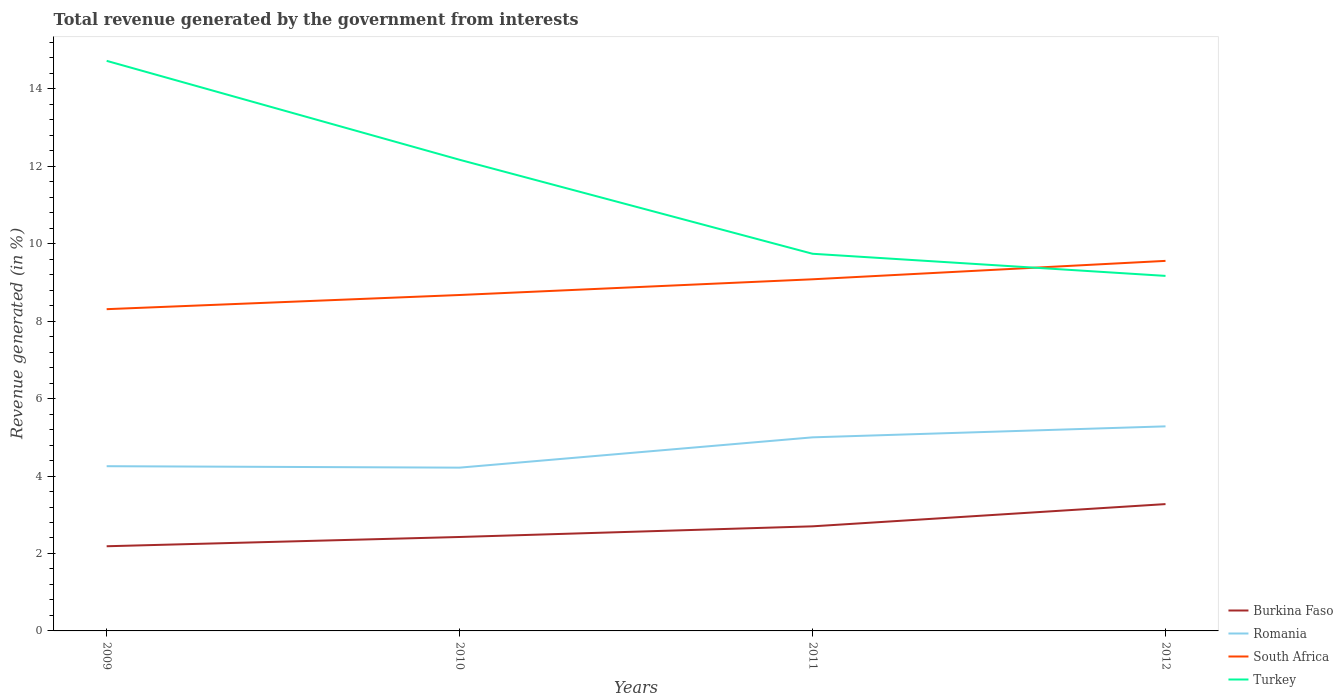Across all years, what is the maximum total revenue generated in Burkina Faso?
Offer a terse response. 2.19. What is the total total revenue generated in Romania in the graph?
Provide a succinct answer. -0.75. What is the difference between the highest and the second highest total revenue generated in South Africa?
Provide a short and direct response. 1.25. How many lines are there?
Make the answer very short. 4. What is the difference between two consecutive major ticks on the Y-axis?
Provide a short and direct response. 2. Does the graph contain grids?
Your answer should be very brief. No. How many legend labels are there?
Your response must be concise. 4. How are the legend labels stacked?
Provide a succinct answer. Vertical. What is the title of the graph?
Provide a short and direct response. Total revenue generated by the government from interests. What is the label or title of the X-axis?
Provide a succinct answer. Years. What is the label or title of the Y-axis?
Keep it short and to the point. Revenue generated (in %). What is the Revenue generated (in %) in Burkina Faso in 2009?
Ensure brevity in your answer.  2.19. What is the Revenue generated (in %) of Romania in 2009?
Your answer should be compact. 4.25. What is the Revenue generated (in %) of South Africa in 2009?
Give a very brief answer. 8.31. What is the Revenue generated (in %) of Turkey in 2009?
Offer a very short reply. 14.72. What is the Revenue generated (in %) in Burkina Faso in 2010?
Your answer should be compact. 2.43. What is the Revenue generated (in %) of Romania in 2010?
Provide a succinct answer. 4.22. What is the Revenue generated (in %) of South Africa in 2010?
Your answer should be very brief. 8.68. What is the Revenue generated (in %) in Turkey in 2010?
Your answer should be very brief. 12.17. What is the Revenue generated (in %) in Burkina Faso in 2011?
Offer a very short reply. 2.7. What is the Revenue generated (in %) of Romania in 2011?
Ensure brevity in your answer.  5. What is the Revenue generated (in %) in South Africa in 2011?
Offer a terse response. 9.08. What is the Revenue generated (in %) of Turkey in 2011?
Provide a short and direct response. 9.74. What is the Revenue generated (in %) of Burkina Faso in 2012?
Provide a succinct answer. 3.28. What is the Revenue generated (in %) of Romania in 2012?
Provide a short and direct response. 5.28. What is the Revenue generated (in %) in South Africa in 2012?
Ensure brevity in your answer.  9.56. What is the Revenue generated (in %) in Turkey in 2012?
Offer a very short reply. 9.17. Across all years, what is the maximum Revenue generated (in %) in Burkina Faso?
Offer a terse response. 3.28. Across all years, what is the maximum Revenue generated (in %) in Romania?
Give a very brief answer. 5.28. Across all years, what is the maximum Revenue generated (in %) in South Africa?
Your response must be concise. 9.56. Across all years, what is the maximum Revenue generated (in %) in Turkey?
Provide a short and direct response. 14.72. Across all years, what is the minimum Revenue generated (in %) in Burkina Faso?
Give a very brief answer. 2.19. Across all years, what is the minimum Revenue generated (in %) in Romania?
Ensure brevity in your answer.  4.22. Across all years, what is the minimum Revenue generated (in %) in South Africa?
Make the answer very short. 8.31. Across all years, what is the minimum Revenue generated (in %) in Turkey?
Give a very brief answer. 9.17. What is the total Revenue generated (in %) of Burkina Faso in the graph?
Your response must be concise. 10.59. What is the total Revenue generated (in %) of Romania in the graph?
Your answer should be compact. 18.75. What is the total Revenue generated (in %) of South Africa in the graph?
Keep it short and to the point. 35.62. What is the total Revenue generated (in %) in Turkey in the graph?
Provide a succinct answer. 45.8. What is the difference between the Revenue generated (in %) in Burkina Faso in 2009 and that in 2010?
Your response must be concise. -0.24. What is the difference between the Revenue generated (in %) in Romania in 2009 and that in 2010?
Provide a succinct answer. 0.04. What is the difference between the Revenue generated (in %) in South Africa in 2009 and that in 2010?
Offer a terse response. -0.37. What is the difference between the Revenue generated (in %) in Turkey in 2009 and that in 2010?
Keep it short and to the point. 2.56. What is the difference between the Revenue generated (in %) of Burkina Faso in 2009 and that in 2011?
Offer a terse response. -0.51. What is the difference between the Revenue generated (in %) of Romania in 2009 and that in 2011?
Keep it short and to the point. -0.75. What is the difference between the Revenue generated (in %) in South Africa in 2009 and that in 2011?
Offer a terse response. -0.77. What is the difference between the Revenue generated (in %) of Turkey in 2009 and that in 2011?
Give a very brief answer. 4.98. What is the difference between the Revenue generated (in %) of Burkina Faso in 2009 and that in 2012?
Provide a succinct answer. -1.09. What is the difference between the Revenue generated (in %) in Romania in 2009 and that in 2012?
Offer a terse response. -1.03. What is the difference between the Revenue generated (in %) in South Africa in 2009 and that in 2012?
Your answer should be compact. -1.25. What is the difference between the Revenue generated (in %) of Turkey in 2009 and that in 2012?
Offer a terse response. 5.55. What is the difference between the Revenue generated (in %) of Burkina Faso in 2010 and that in 2011?
Provide a short and direct response. -0.28. What is the difference between the Revenue generated (in %) of Romania in 2010 and that in 2011?
Provide a short and direct response. -0.78. What is the difference between the Revenue generated (in %) of South Africa in 2010 and that in 2011?
Ensure brevity in your answer.  -0.41. What is the difference between the Revenue generated (in %) in Turkey in 2010 and that in 2011?
Offer a terse response. 2.43. What is the difference between the Revenue generated (in %) of Burkina Faso in 2010 and that in 2012?
Your response must be concise. -0.85. What is the difference between the Revenue generated (in %) of Romania in 2010 and that in 2012?
Your response must be concise. -1.07. What is the difference between the Revenue generated (in %) of South Africa in 2010 and that in 2012?
Ensure brevity in your answer.  -0.88. What is the difference between the Revenue generated (in %) of Turkey in 2010 and that in 2012?
Offer a terse response. 3. What is the difference between the Revenue generated (in %) in Burkina Faso in 2011 and that in 2012?
Your response must be concise. -0.57. What is the difference between the Revenue generated (in %) in Romania in 2011 and that in 2012?
Provide a succinct answer. -0.28. What is the difference between the Revenue generated (in %) of South Africa in 2011 and that in 2012?
Offer a terse response. -0.48. What is the difference between the Revenue generated (in %) of Turkey in 2011 and that in 2012?
Keep it short and to the point. 0.57. What is the difference between the Revenue generated (in %) in Burkina Faso in 2009 and the Revenue generated (in %) in Romania in 2010?
Your answer should be very brief. -2.03. What is the difference between the Revenue generated (in %) in Burkina Faso in 2009 and the Revenue generated (in %) in South Africa in 2010?
Offer a very short reply. -6.49. What is the difference between the Revenue generated (in %) in Burkina Faso in 2009 and the Revenue generated (in %) in Turkey in 2010?
Your answer should be compact. -9.98. What is the difference between the Revenue generated (in %) in Romania in 2009 and the Revenue generated (in %) in South Africa in 2010?
Make the answer very short. -4.42. What is the difference between the Revenue generated (in %) in Romania in 2009 and the Revenue generated (in %) in Turkey in 2010?
Keep it short and to the point. -7.91. What is the difference between the Revenue generated (in %) in South Africa in 2009 and the Revenue generated (in %) in Turkey in 2010?
Keep it short and to the point. -3.86. What is the difference between the Revenue generated (in %) in Burkina Faso in 2009 and the Revenue generated (in %) in Romania in 2011?
Offer a very short reply. -2.81. What is the difference between the Revenue generated (in %) of Burkina Faso in 2009 and the Revenue generated (in %) of South Africa in 2011?
Offer a terse response. -6.89. What is the difference between the Revenue generated (in %) in Burkina Faso in 2009 and the Revenue generated (in %) in Turkey in 2011?
Make the answer very short. -7.55. What is the difference between the Revenue generated (in %) in Romania in 2009 and the Revenue generated (in %) in South Africa in 2011?
Your answer should be compact. -4.83. What is the difference between the Revenue generated (in %) in Romania in 2009 and the Revenue generated (in %) in Turkey in 2011?
Keep it short and to the point. -5.49. What is the difference between the Revenue generated (in %) in South Africa in 2009 and the Revenue generated (in %) in Turkey in 2011?
Provide a short and direct response. -1.43. What is the difference between the Revenue generated (in %) of Burkina Faso in 2009 and the Revenue generated (in %) of Romania in 2012?
Your answer should be very brief. -3.1. What is the difference between the Revenue generated (in %) of Burkina Faso in 2009 and the Revenue generated (in %) of South Africa in 2012?
Make the answer very short. -7.37. What is the difference between the Revenue generated (in %) of Burkina Faso in 2009 and the Revenue generated (in %) of Turkey in 2012?
Provide a succinct answer. -6.98. What is the difference between the Revenue generated (in %) in Romania in 2009 and the Revenue generated (in %) in South Africa in 2012?
Offer a very short reply. -5.3. What is the difference between the Revenue generated (in %) in Romania in 2009 and the Revenue generated (in %) in Turkey in 2012?
Provide a short and direct response. -4.91. What is the difference between the Revenue generated (in %) in South Africa in 2009 and the Revenue generated (in %) in Turkey in 2012?
Offer a terse response. -0.86. What is the difference between the Revenue generated (in %) in Burkina Faso in 2010 and the Revenue generated (in %) in Romania in 2011?
Provide a succinct answer. -2.57. What is the difference between the Revenue generated (in %) in Burkina Faso in 2010 and the Revenue generated (in %) in South Africa in 2011?
Make the answer very short. -6.66. What is the difference between the Revenue generated (in %) of Burkina Faso in 2010 and the Revenue generated (in %) of Turkey in 2011?
Give a very brief answer. -7.31. What is the difference between the Revenue generated (in %) in Romania in 2010 and the Revenue generated (in %) in South Africa in 2011?
Ensure brevity in your answer.  -4.86. What is the difference between the Revenue generated (in %) of Romania in 2010 and the Revenue generated (in %) of Turkey in 2011?
Your answer should be very brief. -5.52. What is the difference between the Revenue generated (in %) of South Africa in 2010 and the Revenue generated (in %) of Turkey in 2011?
Provide a succinct answer. -1.06. What is the difference between the Revenue generated (in %) of Burkina Faso in 2010 and the Revenue generated (in %) of Romania in 2012?
Keep it short and to the point. -2.86. What is the difference between the Revenue generated (in %) in Burkina Faso in 2010 and the Revenue generated (in %) in South Africa in 2012?
Provide a succinct answer. -7.13. What is the difference between the Revenue generated (in %) in Burkina Faso in 2010 and the Revenue generated (in %) in Turkey in 2012?
Your response must be concise. -6.74. What is the difference between the Revenue generated (in %) in Romania in 2010 and the Revenue generated (in %) in South Africa in 2012?
Provide a succinct answer. -5.34. What is the difference between the Revenue generated (in %) of Romania in 2010 and the Revenue generated (in %) of Turkey in 2012?
Your answer should be very brief. -4.95. What is the difference between the Revenue generated (in %) in South Africa in 2010 and the Revenue generated (in %) in Turkey in 2012?
Make the answer very short. -0.49. What is the difference between the Revenue generated (in %) in Burkina Faso in 2011 and the Revenue generated (in %) in Romania in 2012?
Keep it short and to the point. -2.58. What is the difference between the Revenue generated (in %) in Burkina Faso in 2011 and the Revenue generated (in %) in South Africa in 2012?
Ensure brevity in your answer.  -6.86. What is the difference between the Revenue generated (in %) of Burkina Faso in 2011 and the Revenue generated (in %) of Turkey in 2012?
Keep it short and to the point. -6.47. What is the difference between the Revenue generated (in %) in Romania in 2011 and the Revenue generated (in %) in South Africa in 2012?
Offer a very short reply. -4.56. What is the difference between the Revenue generated (in %) of Romania in 2011 and the Revenue generated (in %) of Turkey in 2012?
Offer a terse response. -4.17. What is the difference between the Revenue generated (in %) of South Africa in 2011 and the Revenue generated (in %) of Turkey in 2012?
Provide a short and direct response. -0.09. What is the average Revenue generated (in %) in Burkina Faso per year?
Offer a very short reply. 2.65. What is the average Revenue generated (in %) in Romania per year?
Make the answer very short. 4.69. What is the average Revenue generated (in %) of South Africa per year?
Your answer should be compact. 8.91. What is the average Revenue generated (in %) of Turkey per year?
Offer a very short reply. 11.45. In the year 2009, what is the difference between the Revenue generated (in %) of Burkina Faso and Revenue generated (in %) of Romania?
Make the answer very short. -2.07. In the year 2009, what is the difference between the Revenue generated (in %) of Burkina Faso and Revenue generated (in %) of South Africa?
Ensure brevity in your answer.  -6.12. In the year 2009, what is the difference between the Revenue generated (in %) in Burkina Faso and Revenue generated (in %) in Turkey?
Give a very brief answer. -12.54. In the year 2009, what is the difference between the Revenue generated (in %) of Romania and Revenue generated (in %) of South Africa?
Keep it short and to the point. -4.06. In the year 2009, what is the difference between the Revenue generated (in %) of Romania and Revenue generated (in %) of Turkey?
Make the answer very short. -10.47. In the year 2009, what is the difference between the Revenue generated (in %) of South Africa and Revenue generated (in %) of Turkey?
Your response must be concise. -6.41. In the year 2010, what is the difference between the Revenue generated (in %) of Burkina Faso and Revenue generated (in %) of Romania?
Provide a short and direct response. -1.79. In the year 2010, what is the difference between the Revenue generated (in %) in Burkina Faso and Revenue generated (in %) in South Africa?
Your answer should be compact. -6.25. In the year 2010, what is the difference between the Revenue generated (in %) of Burkina Faso and Revenue generated (in %) of Turkey?
Keep it short and to the point. -9.74. In the year 2010, what is the difference between the Revenue generated (in %) of Romania and Revenue generated (in %) of South Africa?
Your answer should be very brief. -4.46. In the year 2010, what is the difference between the Revenue generated (in %) of Romania and Revenue generated (in %) of Turkey?
Ensure brevity in your answer.  -7.95. In the year 2010, what is the difference between the Revenue generated (in %) of South Africa and Revenue generated (in %) of Turkey?
Offer a terse response. -3.49. In the year 2011, what is the difference between the Revenue generated (in %) in Burkina Faso and Revenue generated (in %) in Romania?
Offer a terse response. -2.3. In the year 2011, what is the difference between the Revenue generated (in %) in Burkina Faso and Revenue generated (in %) in South Africa?
Your answer should be very brief. -6.38. In the year 2011, what is the difference between the Revenue generated (in %) of Burkina Faso and Revenue generated (in %) of Turkey?
Your response must be concise. -7.04. In the year 2011, what is the difference between the Revenue generated (in %) of Romania and Revenue generated (in %) of South Africa?
Provide a short and direct response. -4.08. In the year 2011, what is the difference between the Revenue generated (in %) in Romania and Revenue generated (in %) in Turkey?
Keep it short and to the point. -4.74. In the year 2011, what is the difference between the Revenue generated (in %) of South Africa and Revenue generated (in %) of Turkey?
Ensure brevity in your answer.  -0.66. In the year 2012, what is the difference between the Revenue generated (in %) of Burkina Faso and Revenue generated (in %) of Romania?
Provide a succinct answer. -2.01. In the year 2012, what is the difference between the Revenue generated (in %) of Burkina Faso and Revenue generated (in %) of South Africa?
Offer a terse response. -6.28. In the year 2012, what is the difference between the Revenue generated (in %) of Burkina Faso and Revenue generated (in %) of Turkey?
Make the answer very short. -5.89. In the year 2012, what is the difference between the Revenue generated (in %) of Romania and Revenue generated (in %) of South Africa?
Offer a terse response. -4.27. In the year 2012, what is the difference between the Revenue generated (in %) of Romania and Revenue generated (in %) of Turkey?
Your answer should be compact. -3.89. In the year 2012, what is the difference between the Revenue generated (in %) in South Africa and Revenue generated (in %) in Turkey?
Provide a succinct answer. 0.39. What is the ratio of the Revenue generated (in %) of Burkina Faso in 2009 to that in 2010?
Provide a succinct answer. 0.9. What is the ratio of the Revenue generated (in %) in Romania in 2009 to that in 2010?
Your response must be concise. 1.01. What is the ratio of the Revenue generated (in %) in South Africa in 2009 to that in 2010?
Your answer should be compact. 0.96. What is the ratio of the Revenue generated (in %) of Turkey in 2009 to that in 2010?
Your answer should be very brief. 1.21. What is the ratio of the Revenue generated (in %) in Burkina Faso in 2009 to that in 2011?
Provide a short and direct response. 0.81. What is the ratio of the Revenue generated (in %) in Romania in 2009 to that in 2011?
Give a very brief answer. 0.85. What is the ratio of the Revenue generated (in %) in South Africa in 2009 to that in 2011?
Provide a short and direct response. 0.92. What is the ratio of the Revenue generated (in %) in Turkey in 2009 to that in 2011?
Offer a very short reply. 1.51. What is the ratio of the Revenue generated (in %) in Burkina Faso in 2009 to that in 2012?
Give a very brief answer. 0.67. What is the ratio of the Revenue generated (in %) of Romania in 2009 to that in 2012?
Ensure brevity in your answer.  0.81. What is the ratio of the Revenue generated (in %) of South Africa in 2009 to that in 2012?
Your answer should be compact. 0.87. What is the ratio of the Revenue generated (in %) in Turkey in 2009 to that in 2012?
Your answer should be compact. 1.61. What is the ratio of the Revenue generated (in %) in Burkina Faso in 2010 to that in 2011?
Offer a very short reply. 0.9. What is the ratio of the Revenue generated (in %) of Romania in 2010 to that in 2011?
Your answer should be very brief. 0.84. What is the ratio of the Revenue generated (in %) in South Africa in 2010 to that in 2011?
Give a very brief answer. 0.96. What is the ratio of the Revenue generated (in %) of Turkey in 2010 to that in 2011?
Your answer should be compact. 1.25. What is the ratio of the Revenue generated (in %) in Burkina Faso in 2010 to that in 2012?
Ensure brevity in your answer.  0.74. What is the ratio of the Revenue generated (in %) of Romania in 2010 to that in 2012?
Make the answer very short. 0.8. What is the ratio of the Revenue generated (in %) of South Africa in 2010 to that in 2012?
Offer a very short reply. 0.91. What is the ratio of the Revenue generated (in %) of Turkey in 2010 to that in 2012?
Your answer should be compact. 1.33. What is the ratio of the Revenue generated (in %) of Burkina Faso in 2011 to that in 2012?
Give a very brief answer. 0.82. What is the ratio of the Revenue generated (in %) in Romania in 2011 to that in 2012?
Offer a terse response. 0.95. What is the ratio of the Revenue generated (in %) of South Africa in 2011 to that in 2012?
Your answer should be very brief. 0.95. What is the ratio of the Revenue generated (in %) of Turkey in 2011 to that in 2012?
Your answer should be very brief. 1.06. What is the difference between the highest and the second highest Revenue generated (in %) of Burkina Faso?
Make the answer very short. 0.57. What is the difference between the highest and the second highest Revenue generated (in %) of Romania?
Offer a very short reply. 0.28. What is the difference between the highest and the second highest Revenue generated (in %) of South Africa?
Your answer should be very brief. 0.48. What is the difference between the highest and the second highest Revenue generated (in %) of Turkey?
Make the answer very short. 2.56. What is the difference between the highest and the lowest Revenue generated (in %) of Burkina Faso?
Make the answer very short. 1.09. What is the difference between the highest and the lowest Revenue generated (in %) in Romania?
Provide a succinct answer. 1.07. What is the difference between the highest and the lowest Revenue generated (in %) of South Africa?
Provide a short and direct response. 1.25. What is the difference between the highest and the lowest Revenue generated (in %) in Turkey?
Provide a succinct answer. 5.55. 